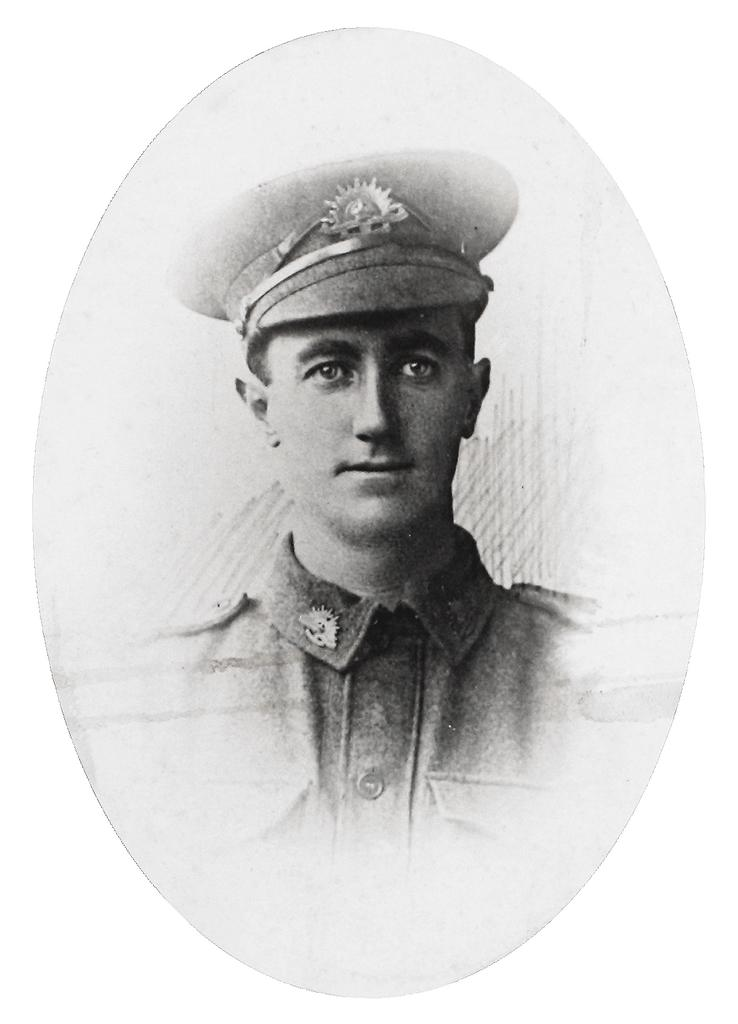What is the main subject of the image? There is a painting in the image. What is depicted in the painting? The painting depicts a man. What is the man wearing on his head? The man is wearing a cap on his head. What type of produce is being harvested in the image? There is no produce or harvesting depicted in the image; it features a painting of a man wearing a cap. How many cards can be seen in the image? There are no cards present in the image. 